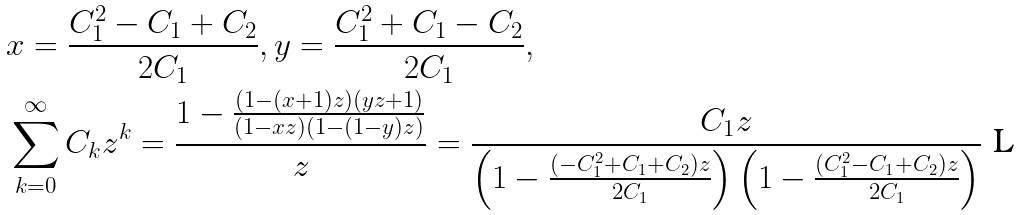Convert formula to latex. <formula><loc_0><loc_0><loc_500><loc_500>& x = \frac { C _ { 1 } ^ { 2 } - C _ { 1 } + C _ { 2 } } { 2 C _ { 1 } } , y = \frac { C _ { 1 } ^ { 2 } + C _ { 1 } - C _ { 2 } } { 2 C _ { 1 } } , \\ & \sum _ { k = 0 } ^ { \infty } C _ { k } z ^ { k } = \frac { 1 - \frac { ( 1 - ( x + 1 ) z ) ( y z + 1 ) } { ( 1 - x z ) ( 1 - ( 1 - y ) z ) } } { z } = \frac { C _ { 1 } z } { \left ( 1 - \frac { \left ( - C _ { 1 } ^ { 2 } + C _ { 1 } + C _ { 2 } \right ) z } { 2 C _ { 1 } } \right ) \left ( 1 - \frac { \left ( C _ { 1 } ^ { 2 } - C _ { 1 } + C _ { 2 } \right ) z } { 2 C _ { 1 } } \right ) }</formula> 